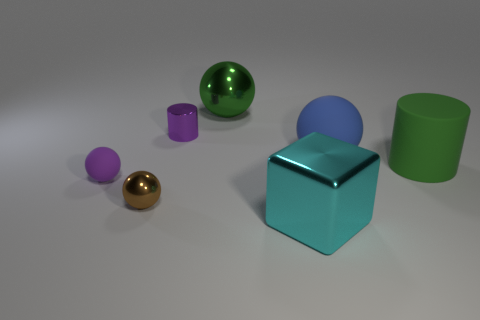Subtract all purple spheres. How many spheres are left? 3 Add 2 blue matte spheres. How many objects exist? 9 Subtract 2 cylinders. How many cylinders are left? 0 Subtract all green balls. How many balls are left? 3 Subtract all purple balls. How many yellow cubes are left? 0 Subtract all shiny cylinders. Subtract all big cyan blocks. How many objects are left? 5 Add 2 large green metal things. How many large green metal things are left? 3 Add 5 brown shiny things. How many brown shiny things exist? 6 Subtract 0 yellow cylinders. How many objects are left? 7 Subtract all cylinders. How many objects are left? 5 